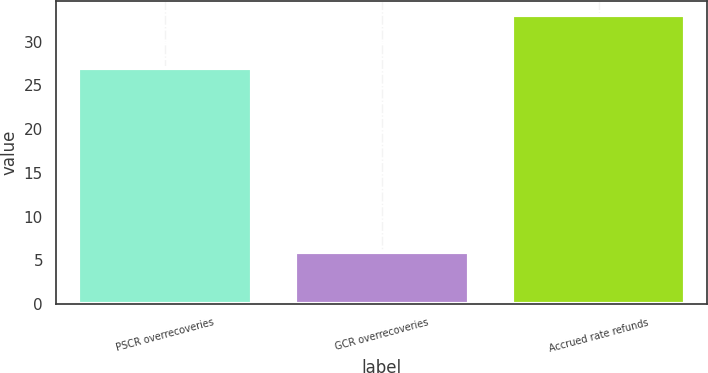Convert chart. <chart><loc_0><loc_0><loc_500><loc_500><bar_chart><fcel>PSCR overrecoveries<fcel>GCR overrecoveries<fcel>Accrued rate refunds<nl><fcel>27<fcel>6<fcel>33<nl></chart> 